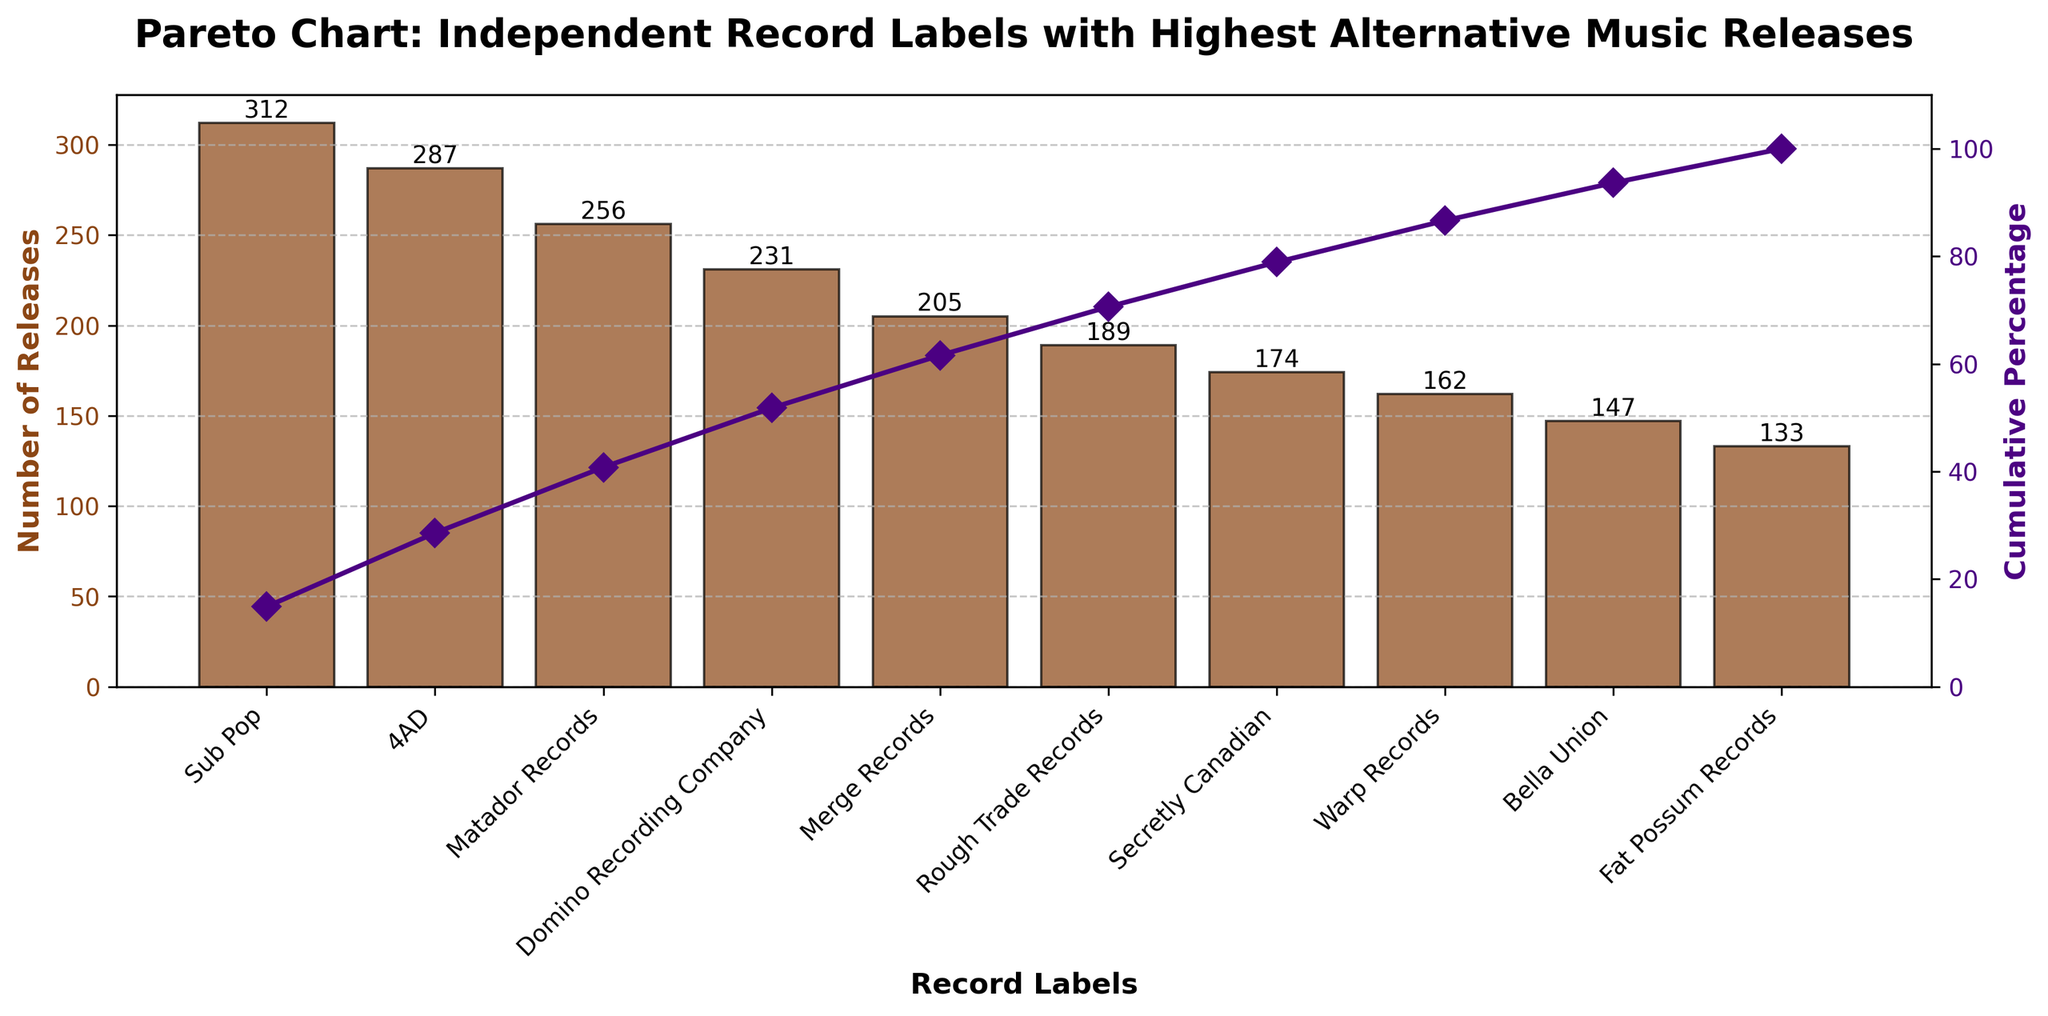What is the title of the Pareto chart? The title of the Pareto chart is displayed at the top of the figure. It states the main topic of the chart, which is related to Independent Record Labels with the highest number of alternative music releases.
Answer: Pareto Chart: Independent Record Labels with Highest Alternative Music Releases What is the label with the highest number of releases? The label with the highest number of releases can be identified by looking at the height of the bars. The tallest bar represents the label with the most releases.
Answer: Sub Pop What is the cumulative percentage of releases covered by the top three labels? To find the cumulative percentage for the top three labels (Sub Pop, 4AD, Matador Records), add their cumulative percentages from the cumulative percentage line. Sub Pop = 19.1%, 4AD = 36.7%, Matador Records = 52.4%.
Answer: 52.4% Which label has the smallest number of releases, and how many releases do they have? The label with the smallest number of releases is identified by the shortest bar. It is located at the far right of the chart.
Answer: Fat Possum Records, 133 How many releases does Merge Records have, and where do they rank among the labels? Locate the bar for Merge Records and read its height to find the number of releases. Look at the position of Merge Records in the sequence from highest to lowest to determine its rank.
Answer: Merge Records has 205 releases and ranks 5th How does Rough Trade Records compare to Secretly Canadian in terms of the number of releases? Compare the heights of the bars for Rough Trade Records and Secretly Canadian. Rough Trade Records has slightly more releases than Secretly Canadian.
Answer: Rough Trade Records has more releases than Secretly Canadian What is the cumulative percentage of releases after including Warp Records? Identify the cumulative percentage from the line on the secondary y-axis at the position of Warp Records.
Answer: 76.2% What is the approximate percentage contribution of Sub Pop to the total releases? Calculate the percentage by dividing the number of releases by Sub Pop by the total number of releases, and then multiply by 100. Sub Pop's contribution = (312 / (sum of all releases)) * 100.
Answer: Approximately 19.1% List the top five labels by the number of releases. Identify the labels corresponding to the tallest five bars in the chart.
Answer: Sub Pop, 4AD, Matador Records, Domino Recording Company, Merge Records 